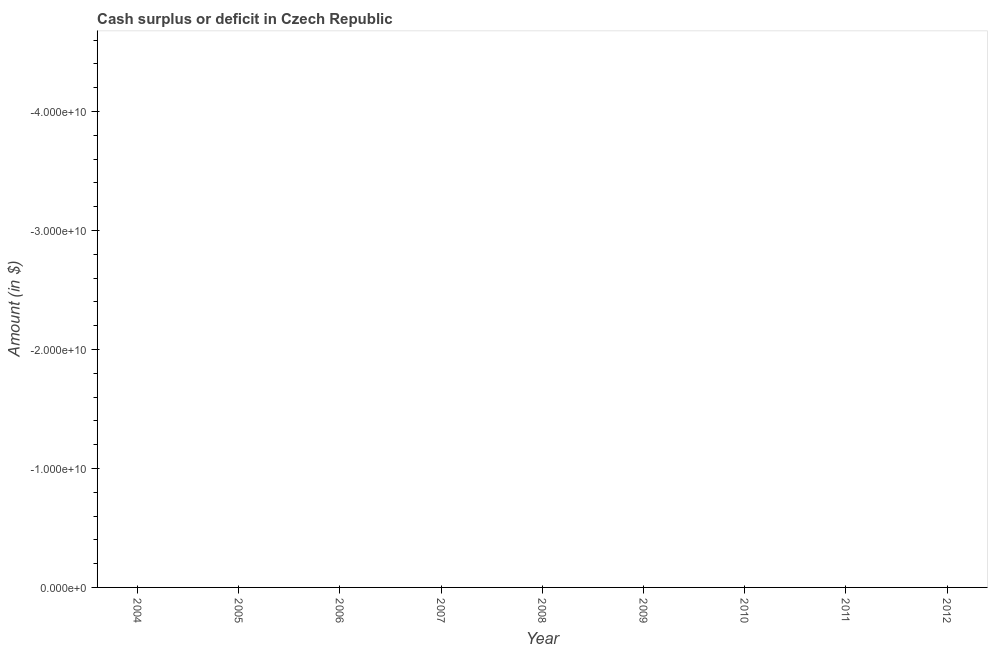What is the cash surplus or deficit in 2006?
Your answer should be compact. 0. Across all years, what is the minimum cash surplus or deficit?
Your response must be concise. 0. What is the sum of the cash surplus or deficit?
Your answer should be very brief. 0. What is the average cash surplus or deficit per year?
Your answer should be very brief. 0. In how many years, is the cash surplus or deficit greater than -44000000000 $?
Provide a succinct answer. 0. How many lines are there?
Give a very brief answer. 0. Does the graph contain any zero values?
Provide a short and direct response. Yes. What is the title of the graph?
Make the answer very short. Cash surplus or deficit in Czech Republic. What is the label or title of the Y-axis?
Make the answer very short. Amount (in $). What is the Amount (in $) in 2005?
Make the answer very short. 0. What is the Amount (in $) in 2006?
Your answer should be very brief. 0. What is the Amount (in $) of 2007?
Offer a terse response. 0. What is the Amount (in $) of 2008?
Keep it short and to the point. 0. What is the Amount (in $) of 2009?
Make the answer very short. 0. What is the Amount (in $) of 2010?
Your response must be concise. 0. What is the Amount (in $) of 2011?
Keep it short and to the point. 0. 